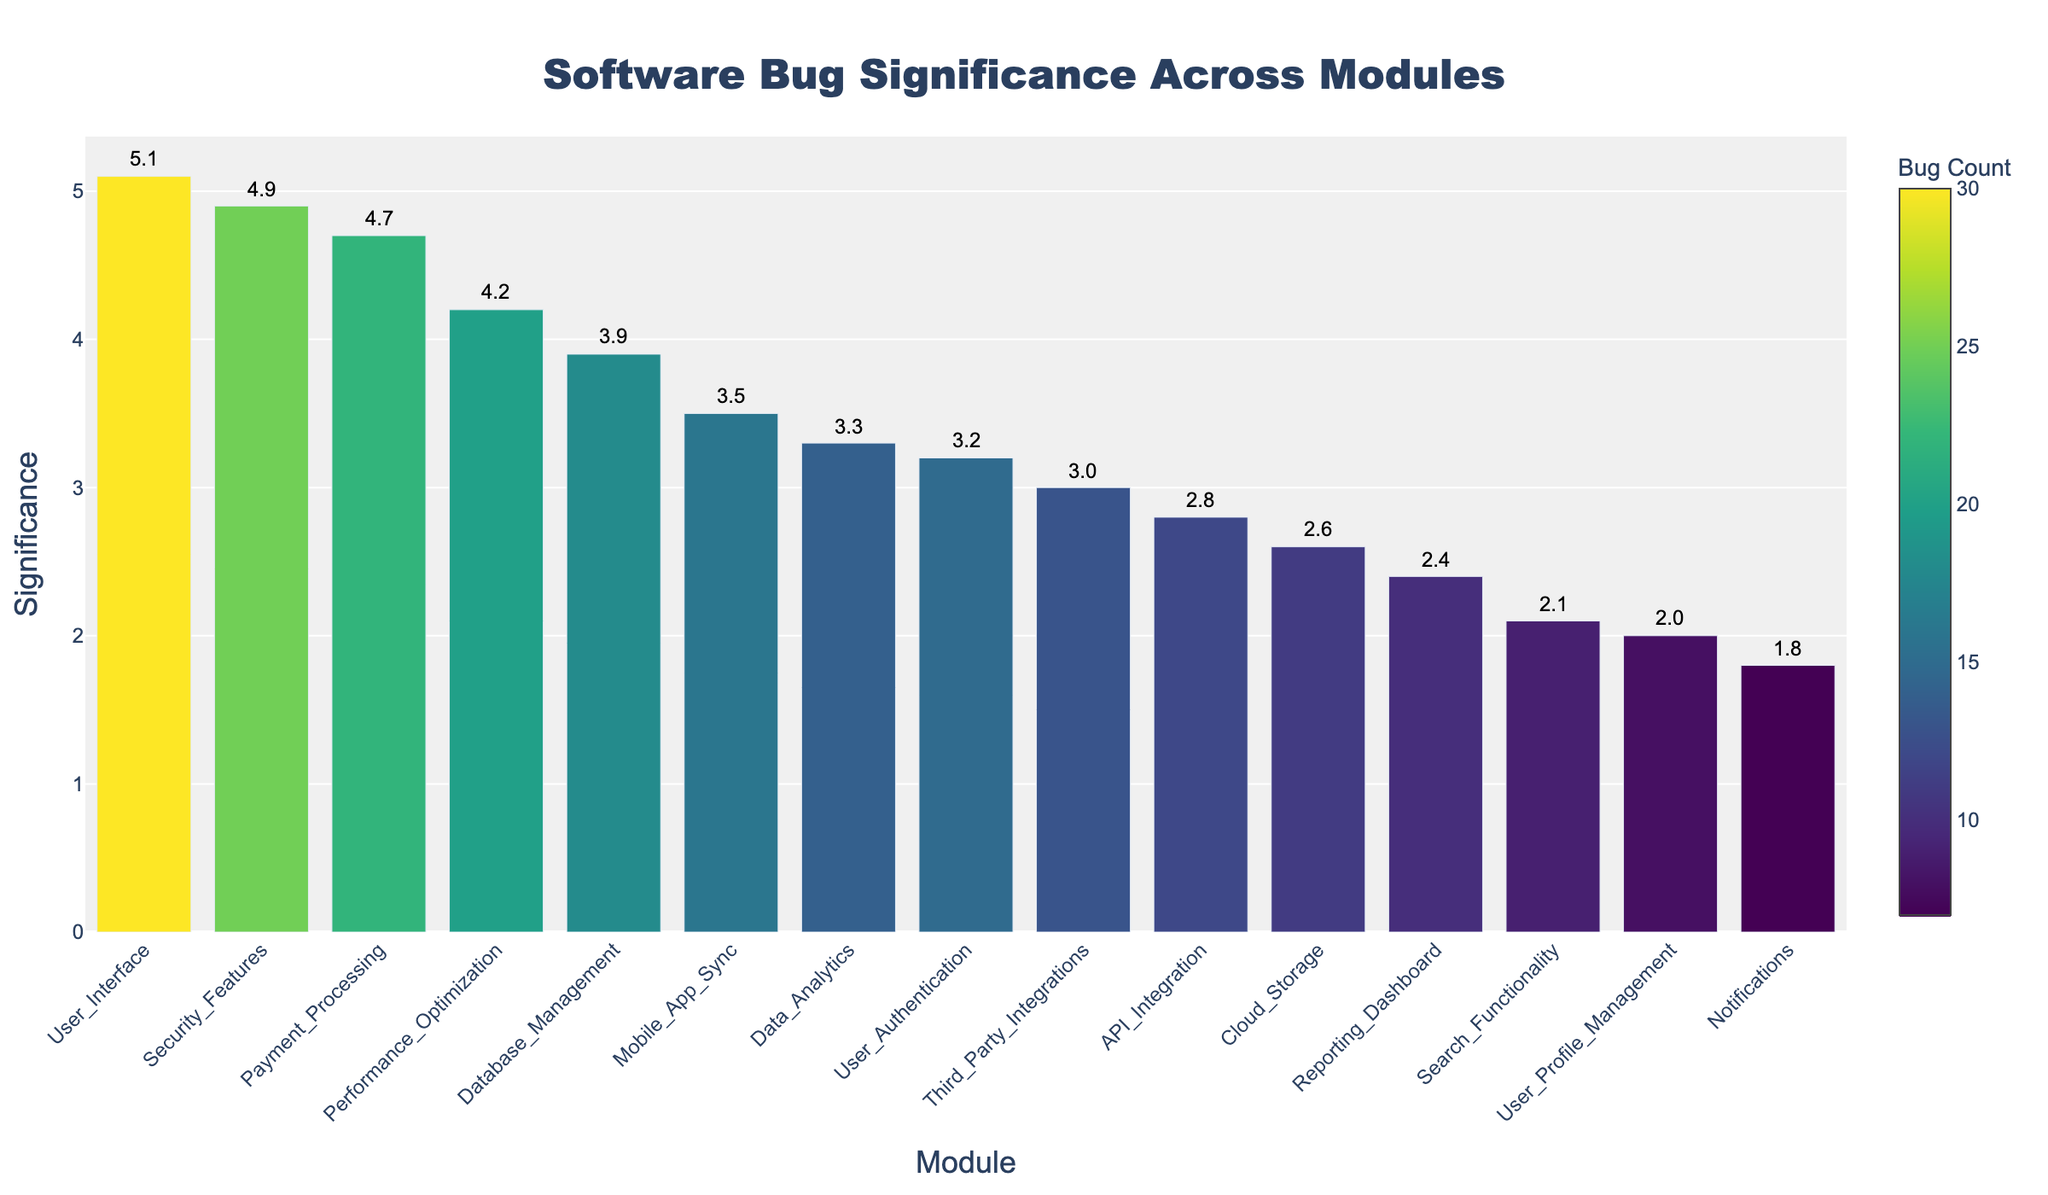what is the significance of the 'User_Interface' module? Find the bar labeled 'User_Interface' on the x-axis and read its corresponding y-axis value. The significance is displayed as 5.1
Answer: 5.1 Which module has the highest significance, and what is its value? Identify the bar with the greatest height on the figure. Hovering over it or reading the largest y-axis value indicates that 'User_Interface' has the highest significance of 5.1
Answer: User_Interface, 5.1 How many modules have a significance value greater than 4? Count the number of bars that extend above the 4 mark on the y-axis. These are 'User_Interface', 'Security_Features', 'Payment_Processing', and 'Performance_Optimization', totaling 4
Answer: 4 What is the average significance of all modules? Sum all significance values: 3.2 + 4.7 + 3.9 + 2.8 + 5.1 + 2.1 + 1.8 + 3.3 + 2.6 + 4.2 + 4.9 + 3.5 + 3.0 + 2.4 + 2.0 = 45.5. There are 15 modules. The average is 45.5 / 15 = 3.03
Answer: 3.03 Which module has a bug count of 22, and what is its significance? Using the color legend for bug counts, locate the bar predominantly in the color shade representing 22, hover over it or read the module name and significance displayed. It corresponds to 'Payment_Processing', significance 4.7
Answer: Payment_Processing, 4.7 What is the difference in significance between 'Database_Management' and 'Search_Functionality'? Locate bars for 'Database_Management' and 'Search_Functionality'. Their significance values are 3.9 and 2.1, respectively. The difference is 3.9 - 2.1 = 1.8
Answer: 1.8 Which modules have a bug count higher than 20, and what are their significance values? Locate bars with colors representing bug counts greater than 20, these modules are 'User_Interface' and 'Security_Features'. Their significance values are 5.1 and 4.9
Answer: User_Interface: 5.1, Security_Features: 4.9 What is the color scale used to indicate bug counts? Observe the color gradient on the color bar legend, which ranges from light to dark shades. The colors range from lighter yellow-green tones to darker purple tones
Answer: Viridis color scale What is the median significance value? Arrange significance values in ascending order: 1.8, 2.0, 2.1, 2.4, 2.6, 2.8, 3.0, 3.2, 3.3, 3.5, 3.9, 4.2, 4.7, 4.9, 5.1. The median value (the eighth in this order) is 3.3
Answer: 3.3 What is the total count of data points displayed in the figure? Count all distinct modules (bars) in the figure presented along the x-axis. There are 15 modules
Answer: 15 